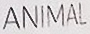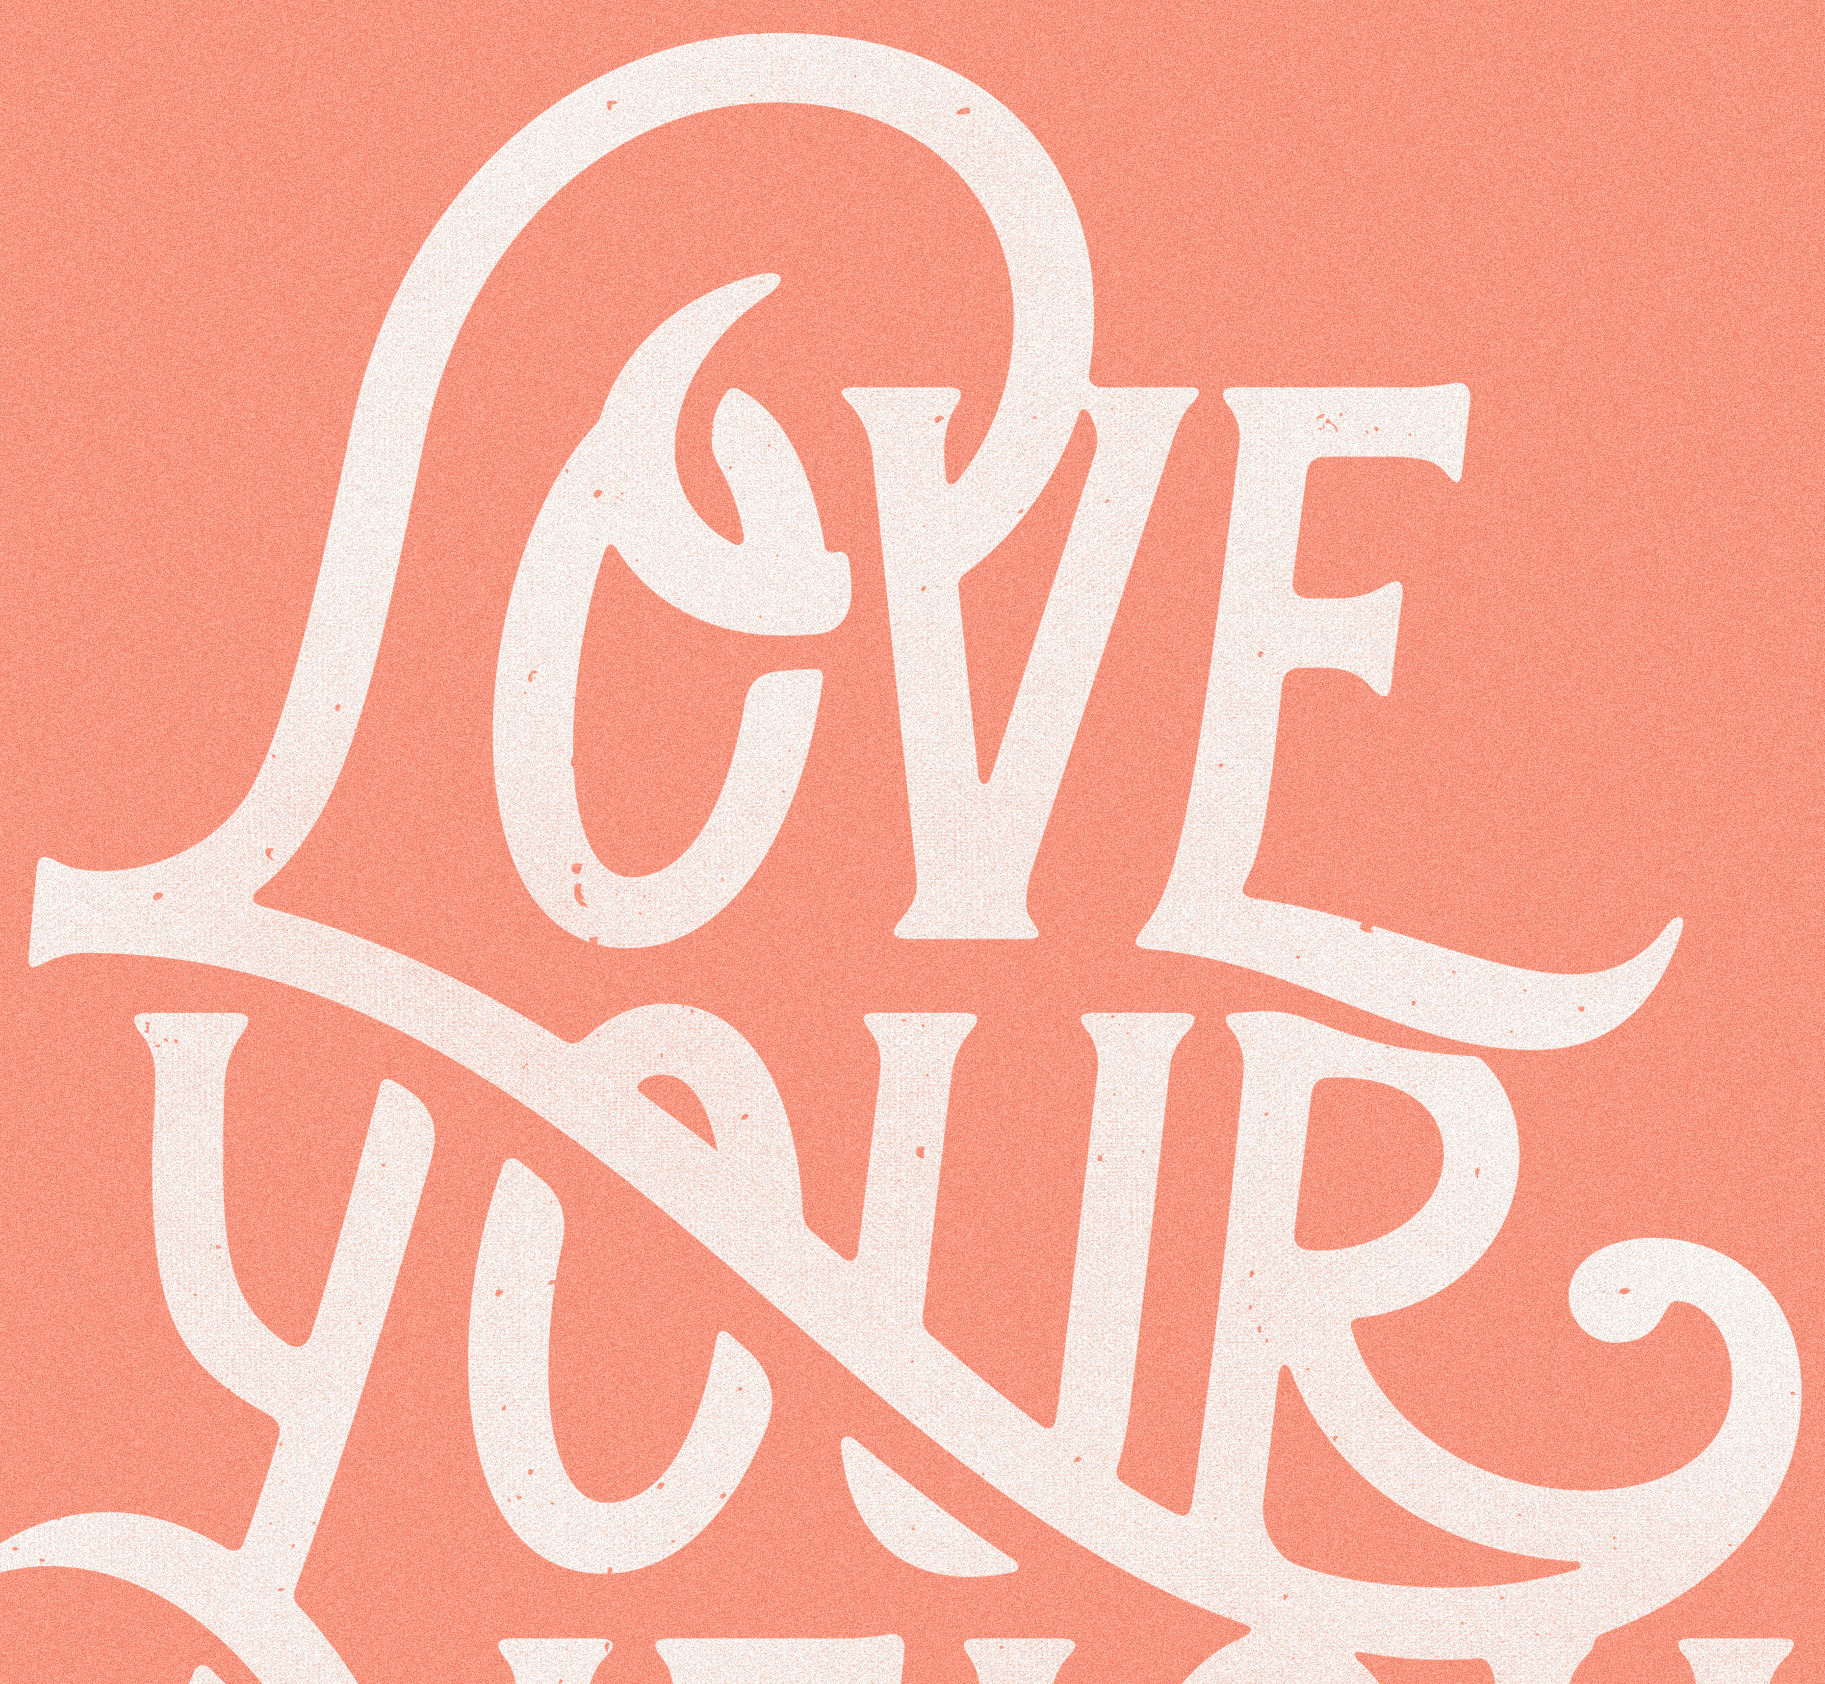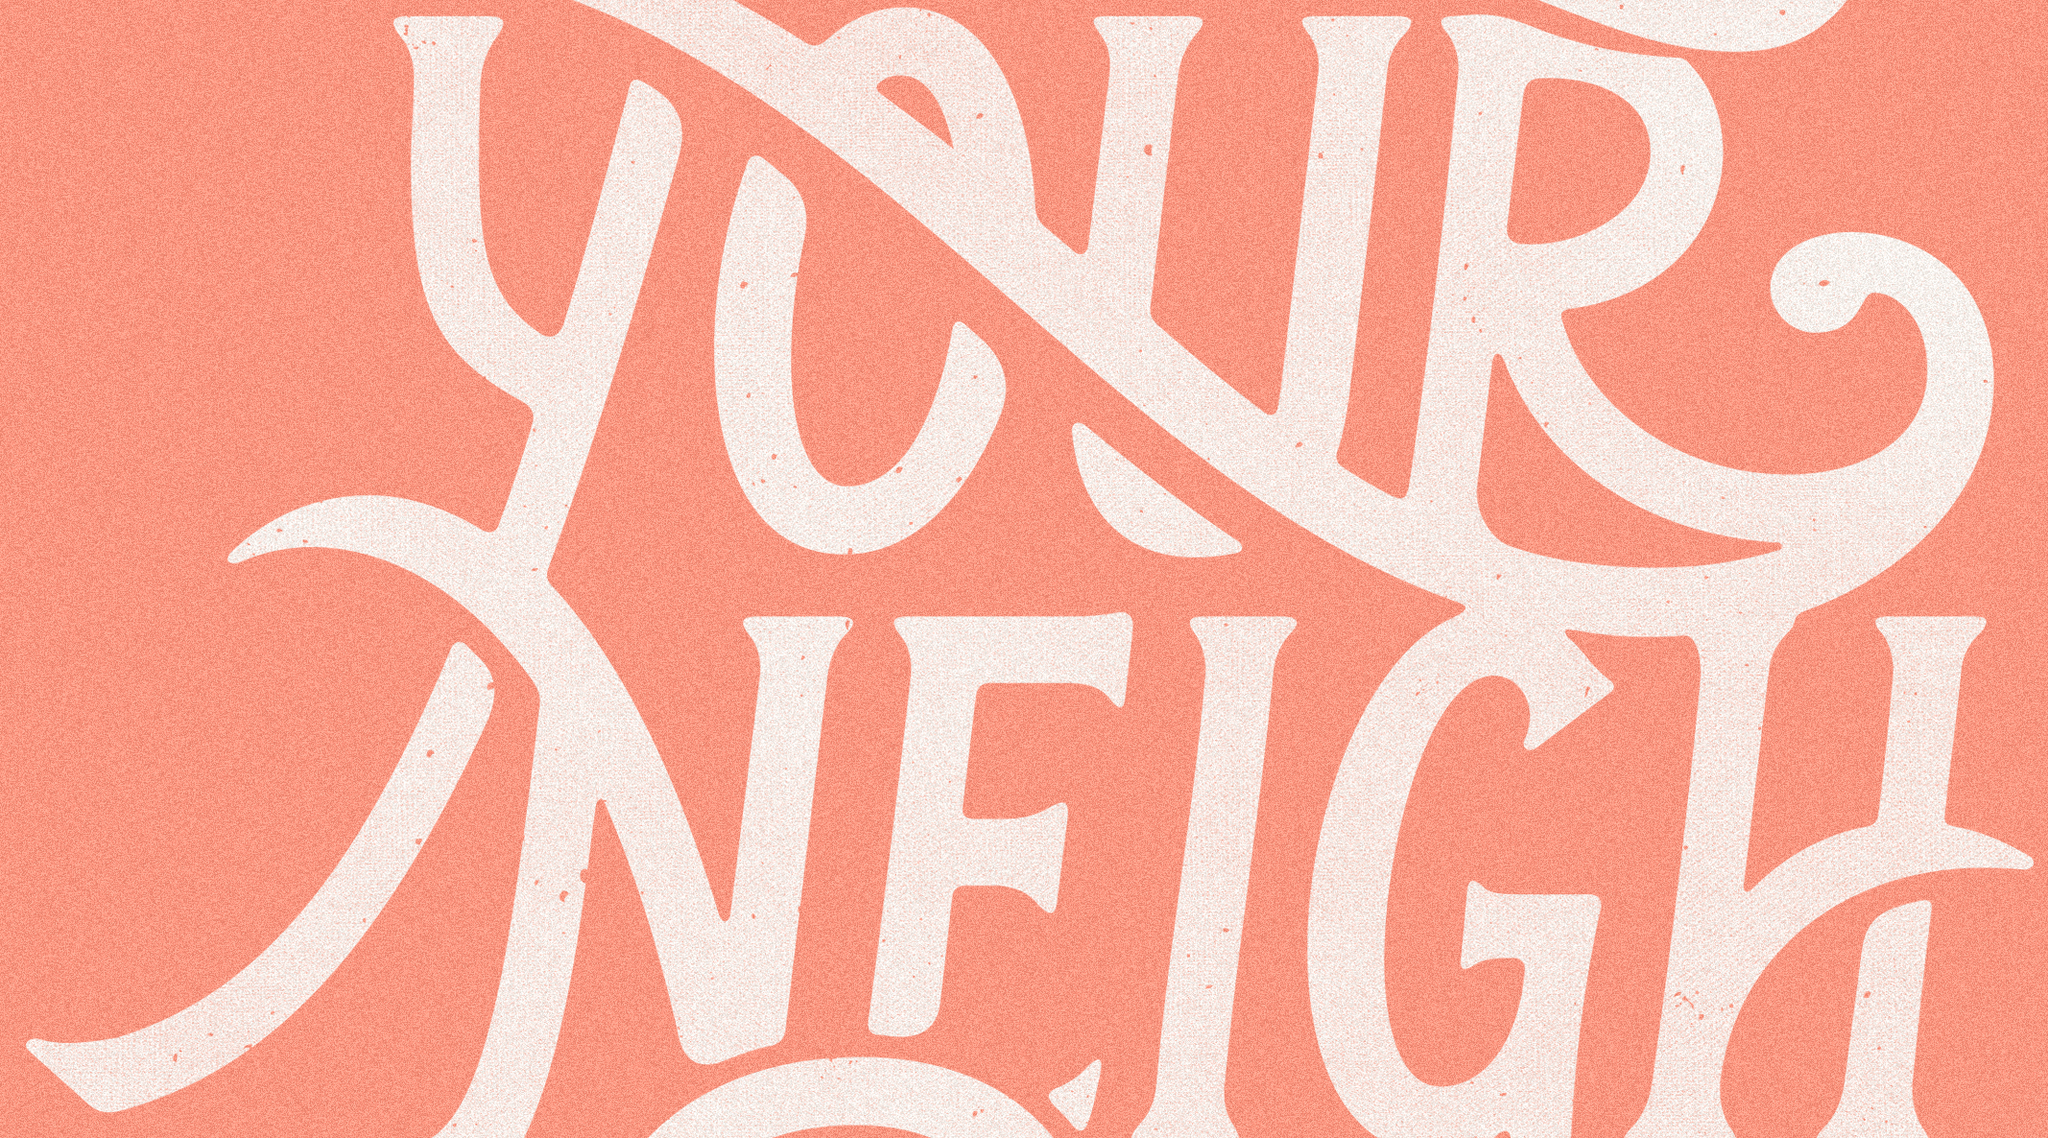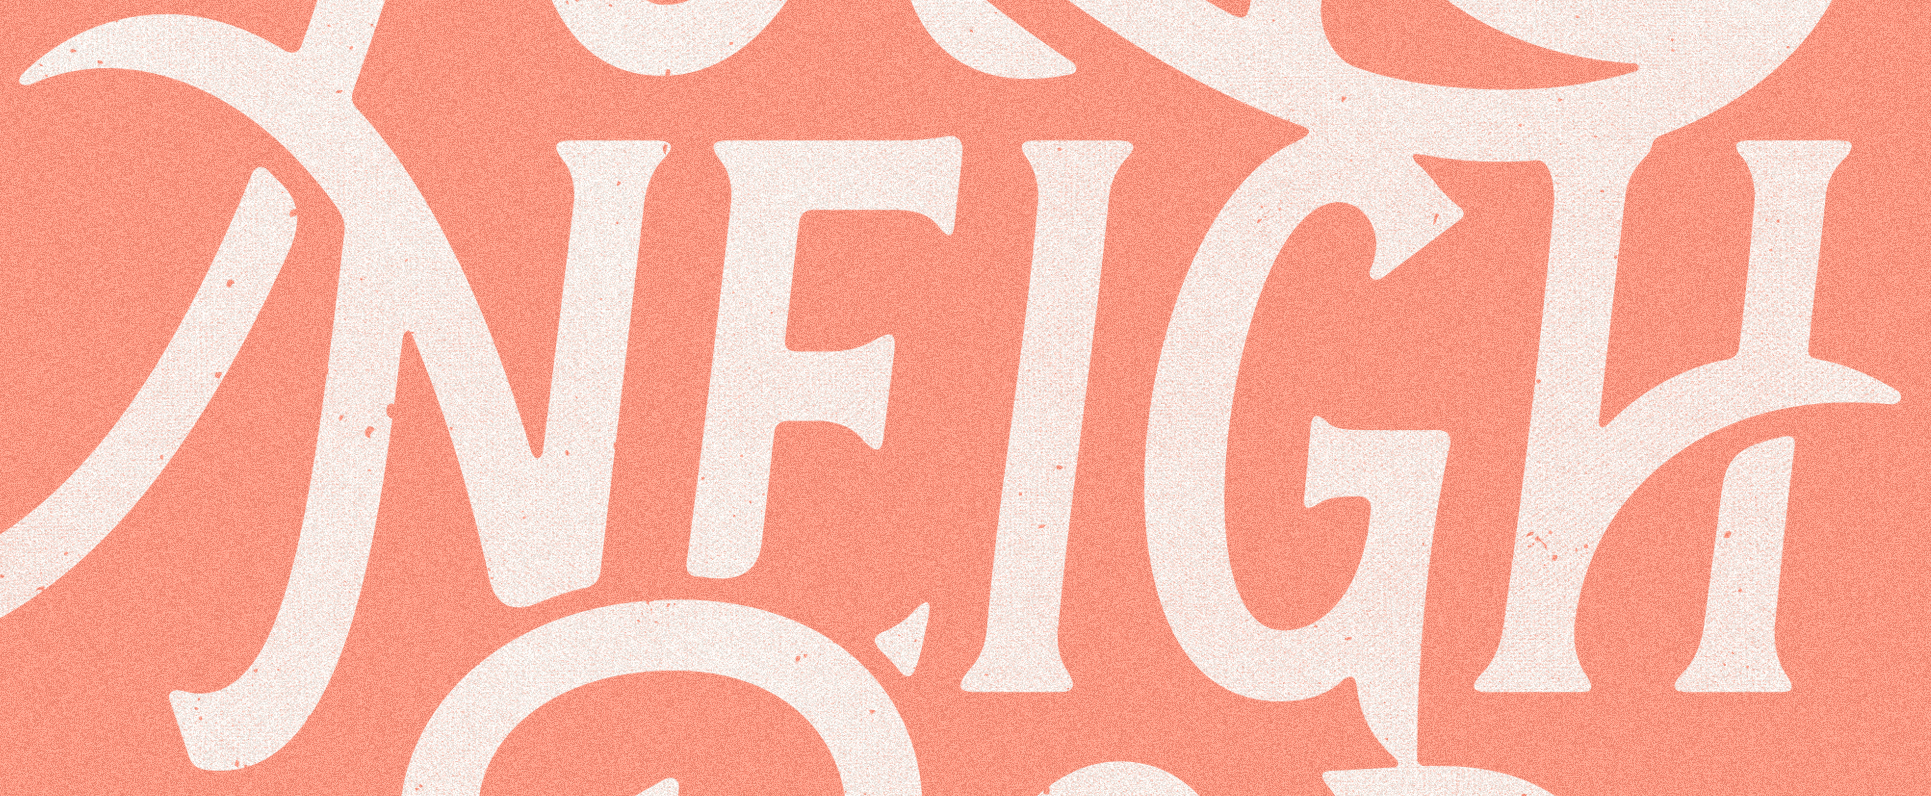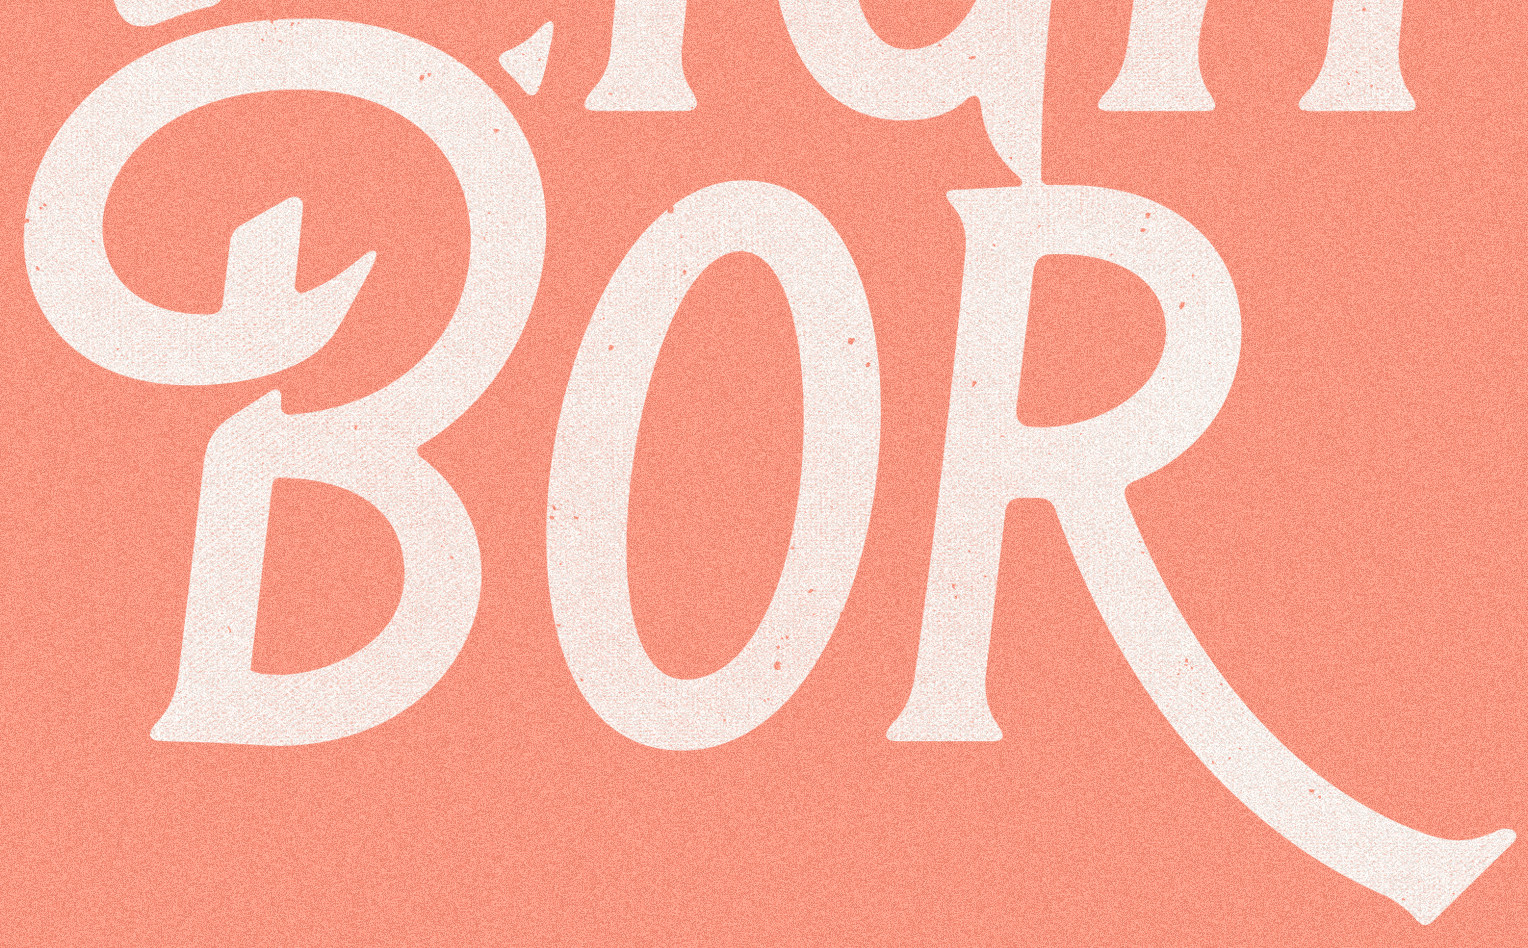Read the text content from these images in order, separated by a semicolon. ANIMAL; LOVE; YOUR; NEIGH; BOR 